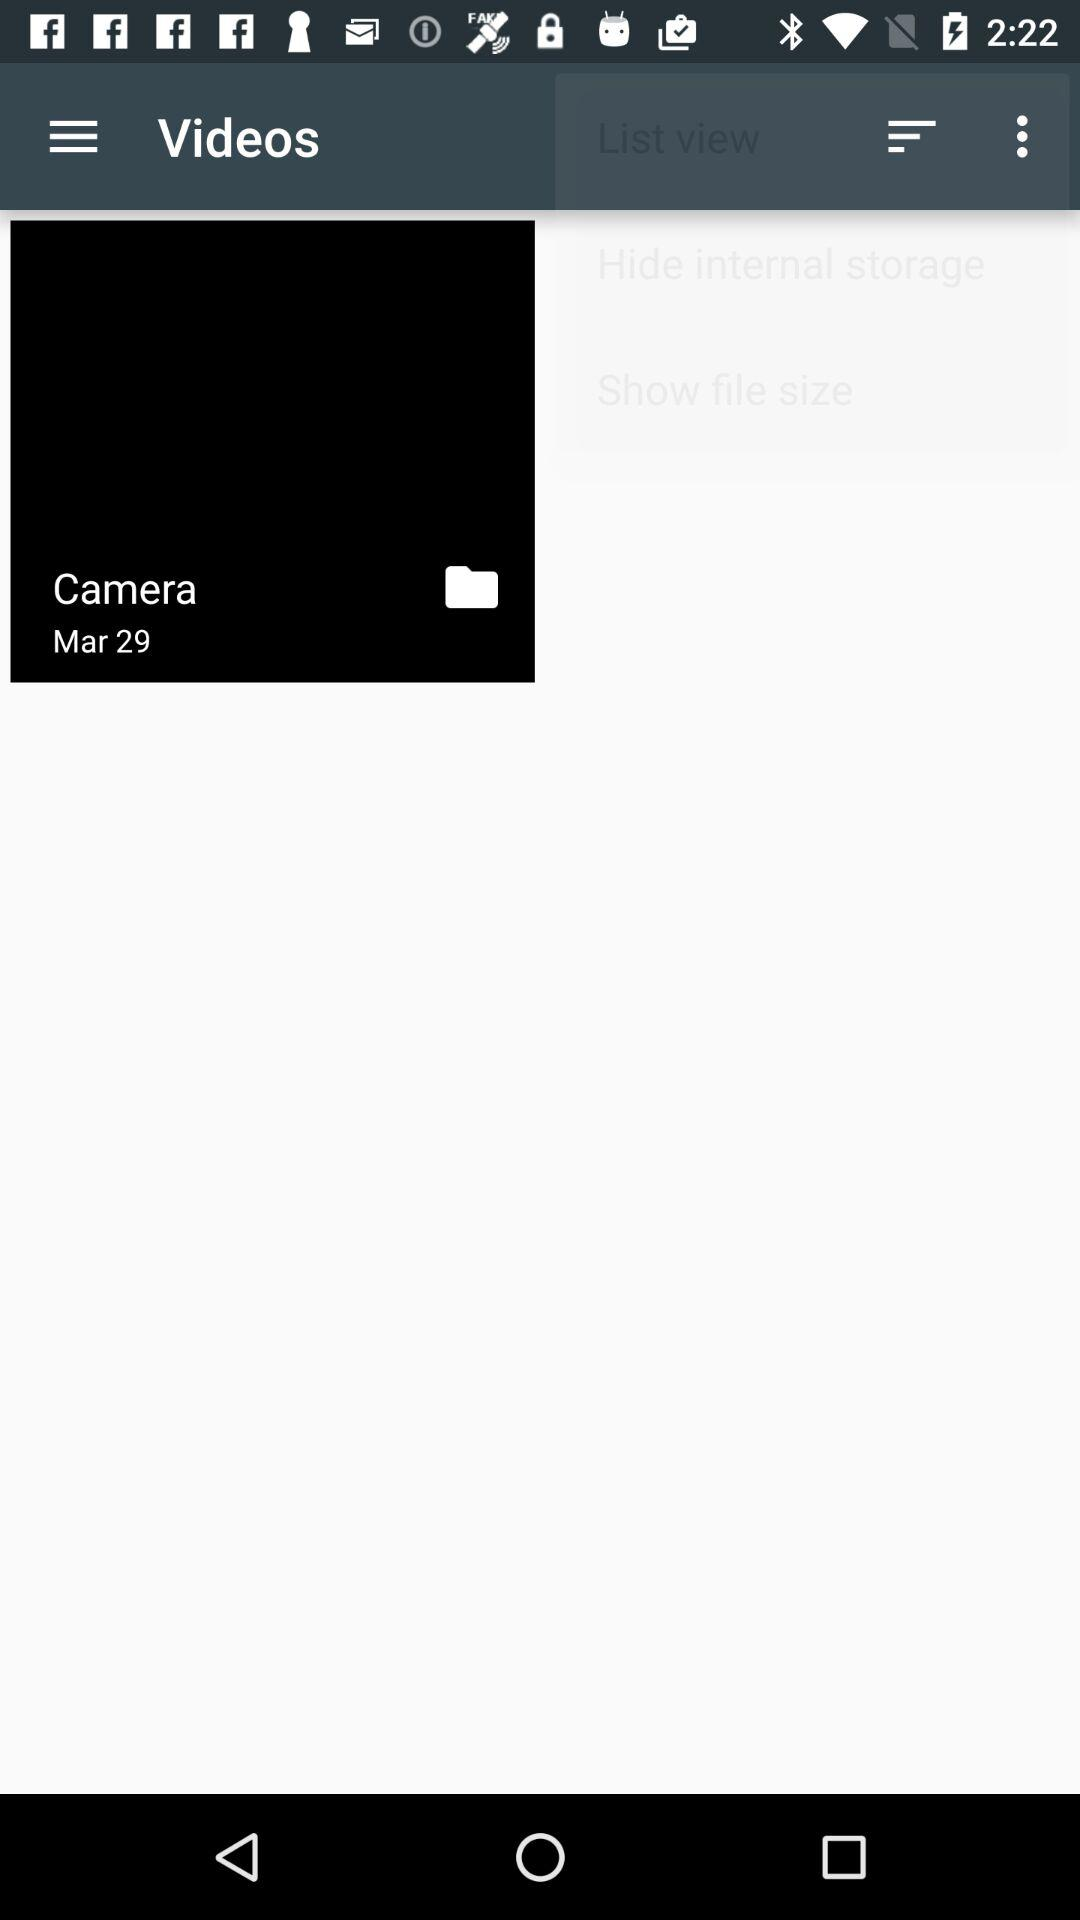What's the folder name? The folder name is "Camera". 